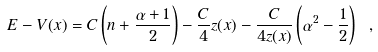Convert formula to latex. <formula><loc_0><loc_0><loc_500><loc_500>E - V ( x ) = C \left ( n + \frac { \alpha + 1 } { 2 } \right ) - \frac { C } { 4 } z ( x ) - \frac { C } { 4 z ( x ) } \left ( \alpha ^ { 2 } - \frac { 1 } { 2 } \right ) \ ,</formula> 